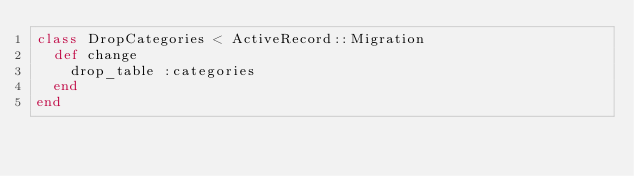<code> <loc_0><loc_0><loc_500><loc_500><_Ruby_>class DropCategories < ActiveRecord::Migration
  def change
    drop_table :categories
  end
end
</code> 